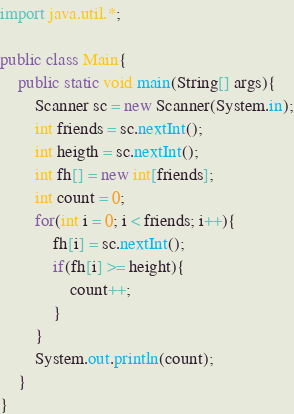<code> <loc_0><loc_0><loc_500><loc_500><_Java_>import java.util.*;
 
public class Main{
	public static void main(String[] args){
	    Scanner sc = new Scanner(System.in);
    	int friends = sc.nextInt();
        int heigth = sc.nextInt();
        int fh[] = new int[friends];
        int count = 0;
        for(int i = 0; i < friends; i++){
        	fh[i] = sc.nextInt();
            if(fh[i] >= height){
            	count++;
            }
        }
        System.out.println(count);
	}
}</code> 